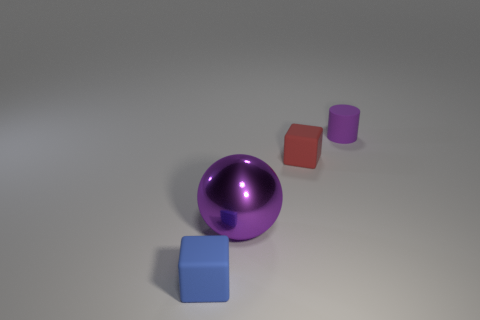Add 4 things. How many objects exist? 8 Subtract all spheres. How many objects are left? 3 Add 3 blue things. How many blue things exist? 4 Subtract 1 purple balls. How many objects are left? 3 Subtract all purple rubber things. Subtract all large purple metallic things. How many objects are left? 2 Add 1 purple matte cylinders. How many purple matte cylinders are left? 2 